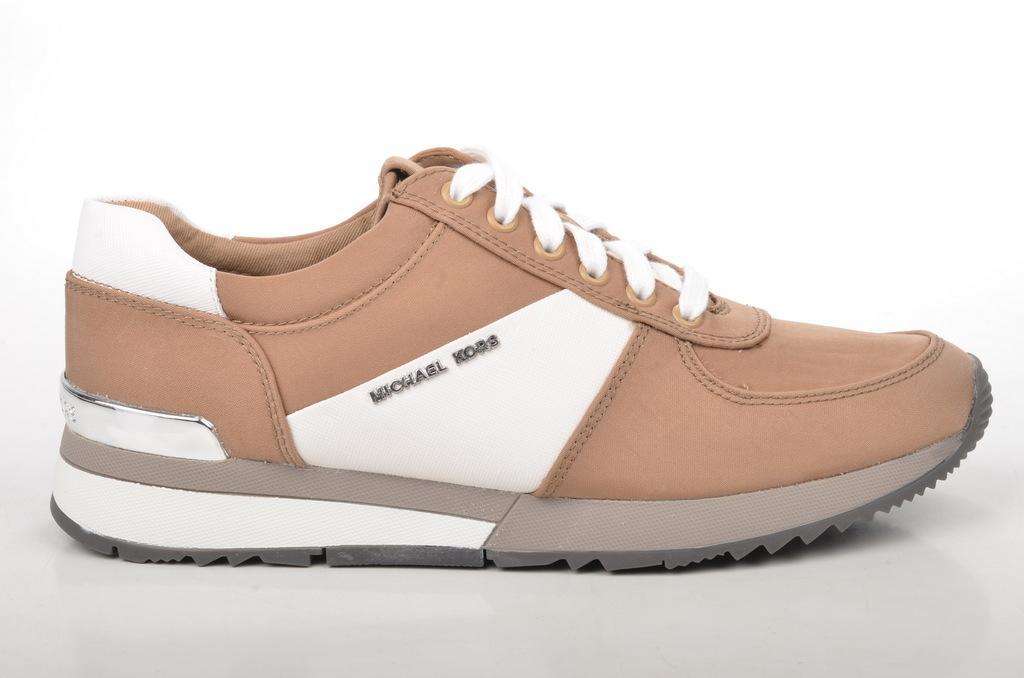Can you describe this image briefly? In this image we can see a shoe and a white background. 